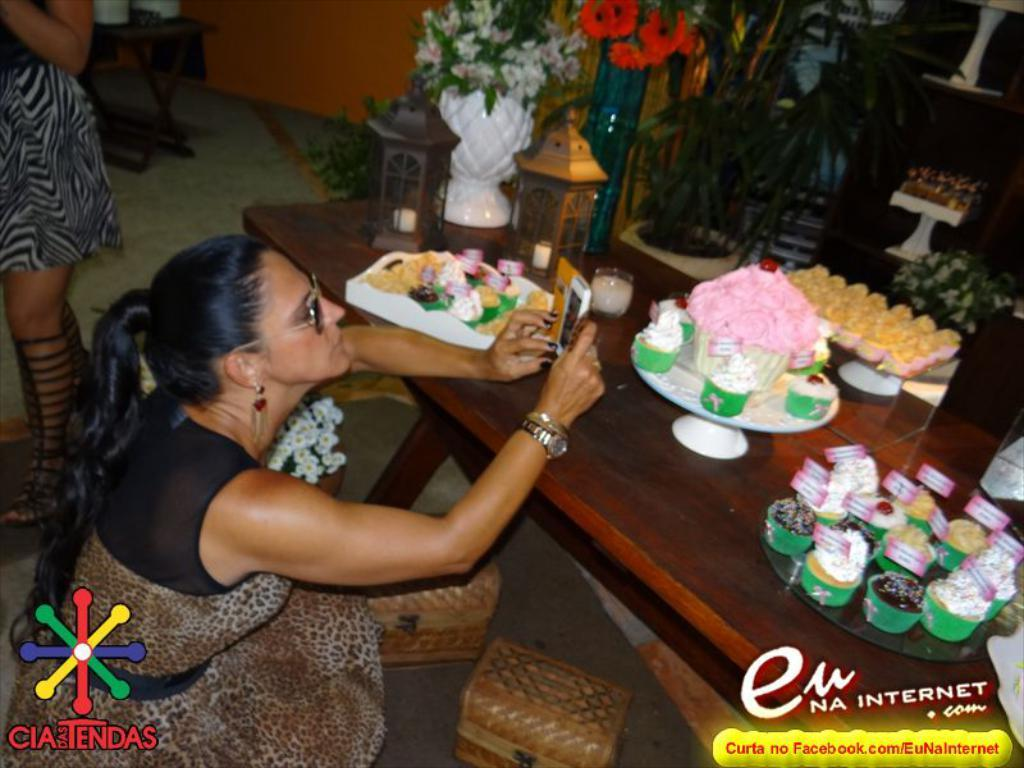Who is present in the image? There is a woman in the image. What is the woman wearing on her face? The woman is wearing goggles. What is on the table in the image? There is a cake, muffins, and a flowers vase on the table. What type of surface is visible beneath the table? There is a floor visible in the image. What is the background of the image made of? There is a wall in the image. How many chickens are sitting on the table in the image? There are no chickens present in the image; the table has a cake, muffins, and a flowers vase. What type of pen is the woman holding in the image? There is no pen visible in the image; the woman is wearing goggles. 